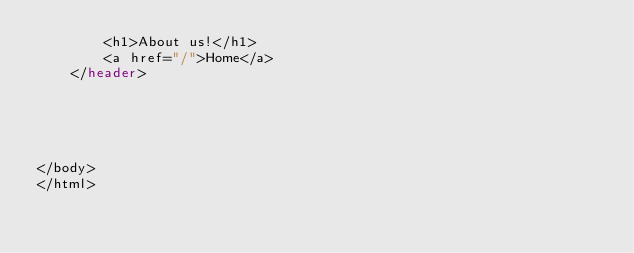<code> <loc_0><loc_0><loc_500><loc_500><_PHP_>        <h1>About us!</h1>
        <a href="/">Home</a>
    </header>





</body>
</html></code> 